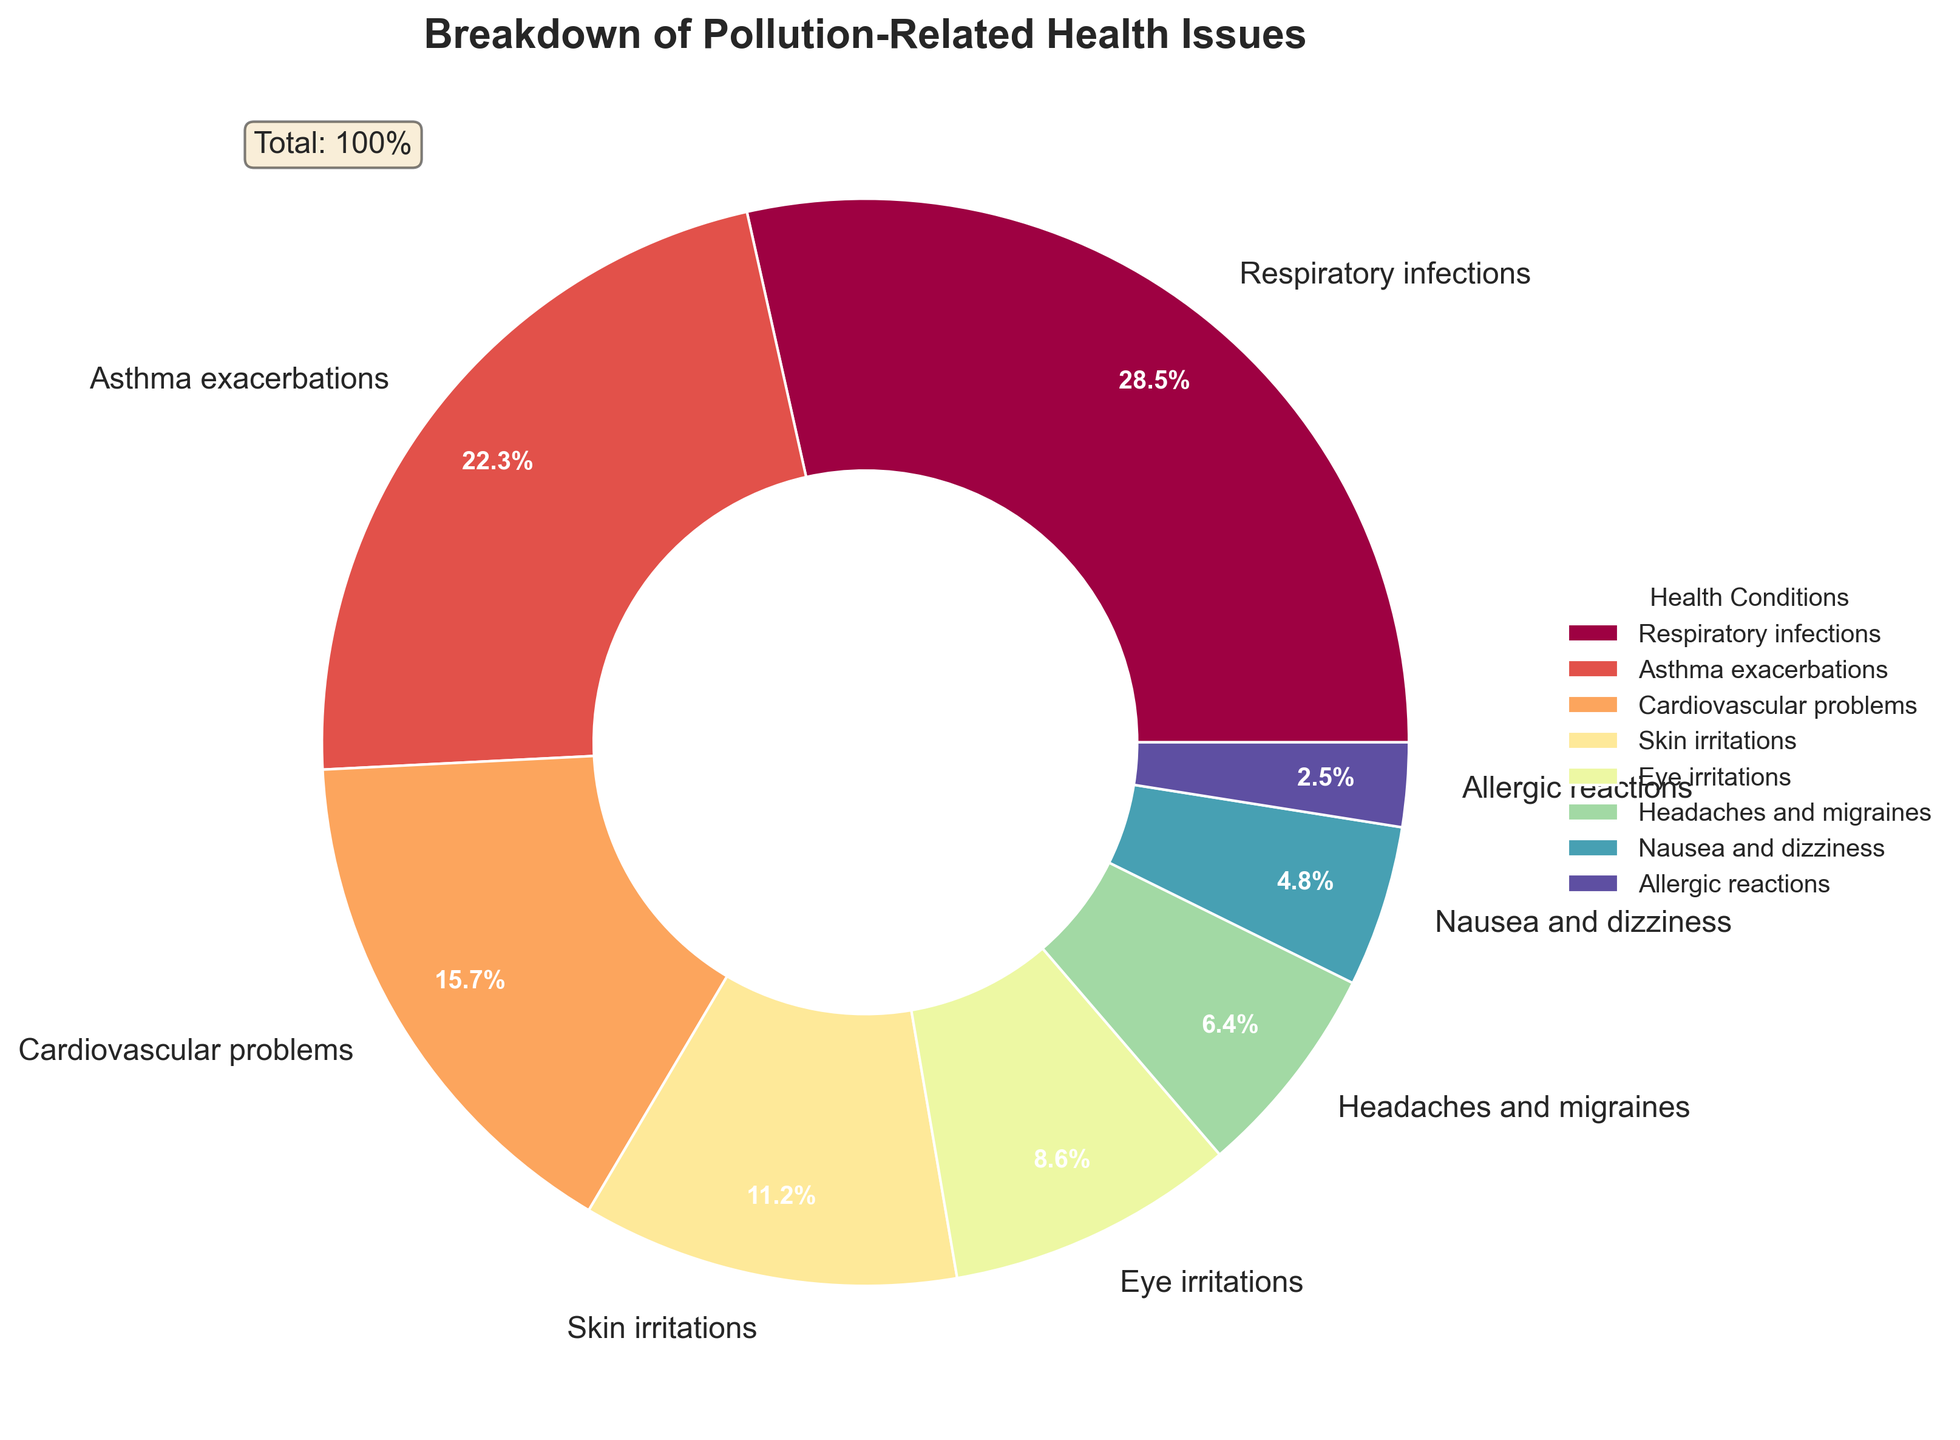Which condition has the highest percentage of reported health issues? From the pie chart, look for the section with the largest slice. The condition associated with 28.5% of the health issues is clearly labeled as 'Respiratory infections'.
Answer: Respiratory infections Which condition has the lowest percentage? On the pie chart, identify the smallest slice. The section with 2.5% is labeled as 'Allergic reactions'.
Answer: Allergic reactions What is the combined percentage for Asthma exacerbations and Cardiovascular problems? Locate the percentages for 'Asthma exacerbations' (22.3%) and 'Cardiovascular problems' (15.7%). Add these two values together: 22.3 + 15.7 = 38.0%.
Answer: 38.0% How much more common are Respiratory infections compared to Eye irritations? Locate the percentages for 'Respiratory infections' (28.5%) and 'Eye irritations' (8.6%). Subtract the smaller percentage from the larger one: 28.5 - 8.6 = 19.9%.
Answer: 19.9% Are Skin irritations more common than Headaches and migraines? Compare the percentages for 'Skin irritations' (11.2%) and 'Headaches and migraines' (6.4%). Since 11.2% is greater than 6.4%, Skin irritations are indeed more common.
Answer: Yes How many conditions have a reported percentage of 10% or higher? Examine the slices in the pie chart with labels showing percentages. Those with 10% or higher are 'Respiratory infections' (28.5%), 'Asthma exacerbations' (22.3%), 'Cardiovascular problems' (15.7%), and 'Skin irritations' (11.2%). There are a total of 4 such conditions.
Answer: 4 What is the average percentage for Eye irritations and Nausea and dizziness? Locate the percentages for 'Eye irritations' (8.6%) and 'Nausea and dizziness' (4.8%). Add these values, then divide by 2 to find the average: (8.6 + 4.8) / 2 = 6.7%.
Answer: 6.7% Which condition has a percentage closest to 5%? Search for the percentage that is the closest to 5%. 'Nausea and dizziness' at 4.8% is the nearest.
Answer: Nausea and dizziness What is the total percentage for the conditions other than Respiratory infections and Asthma exacerbations? Find the combined percentage of all conditions excluding 'Respiratory infections' (28.5%) and 'Asthma exacerbations' (22.3%). Sum the remaining: 15.7 + 11.2 + 8.6 + 6.4 + 4.8 + 2.5 = 49.2%.
Answer: 49.2% 